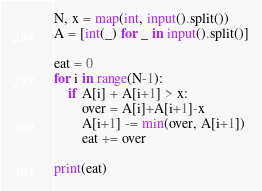<code> <loc_0><loc_0><loc_500><loc_500><_Python_>N, x = map(int, input().split())
A = [int(_) for _ in input().split()]

eat = 0
for i in range(N-1):
    if A[i] + A[i+1] > x:
        over = A[i]+A[i+1]-x
        A[i+1] -= min(over, A[i+1])
        eat += over

print(eat)</code> 